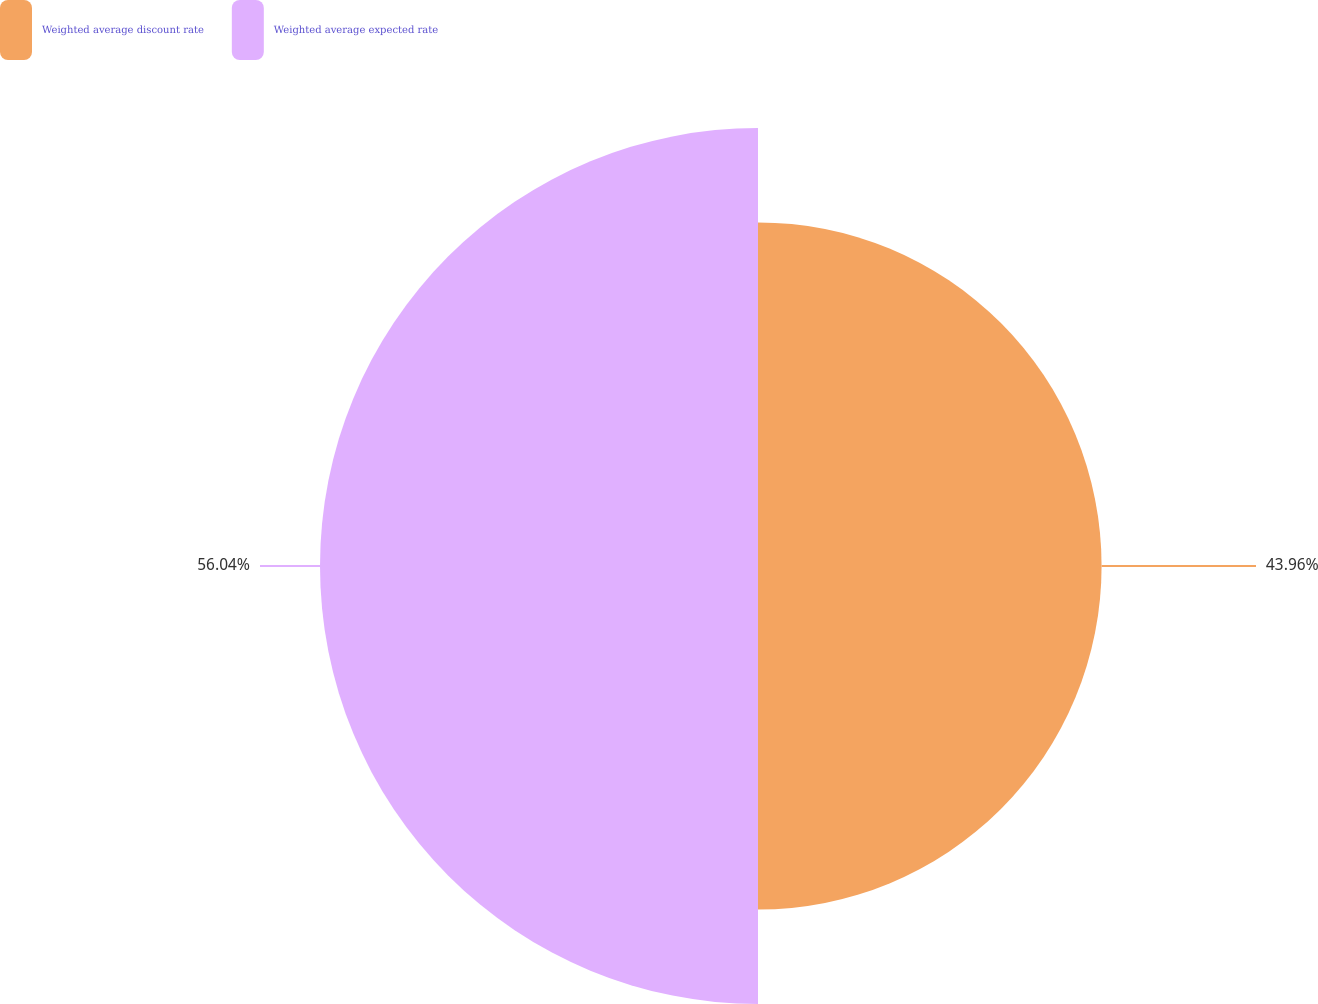<chart> <loc_0><loc_0><loc_500><loc_500><pie_chart><fcel>Weighted average discount rate<fcel>Weighted average expected rate<nl><fcel>43.96%<fcel>56.04%<nl></chart> 